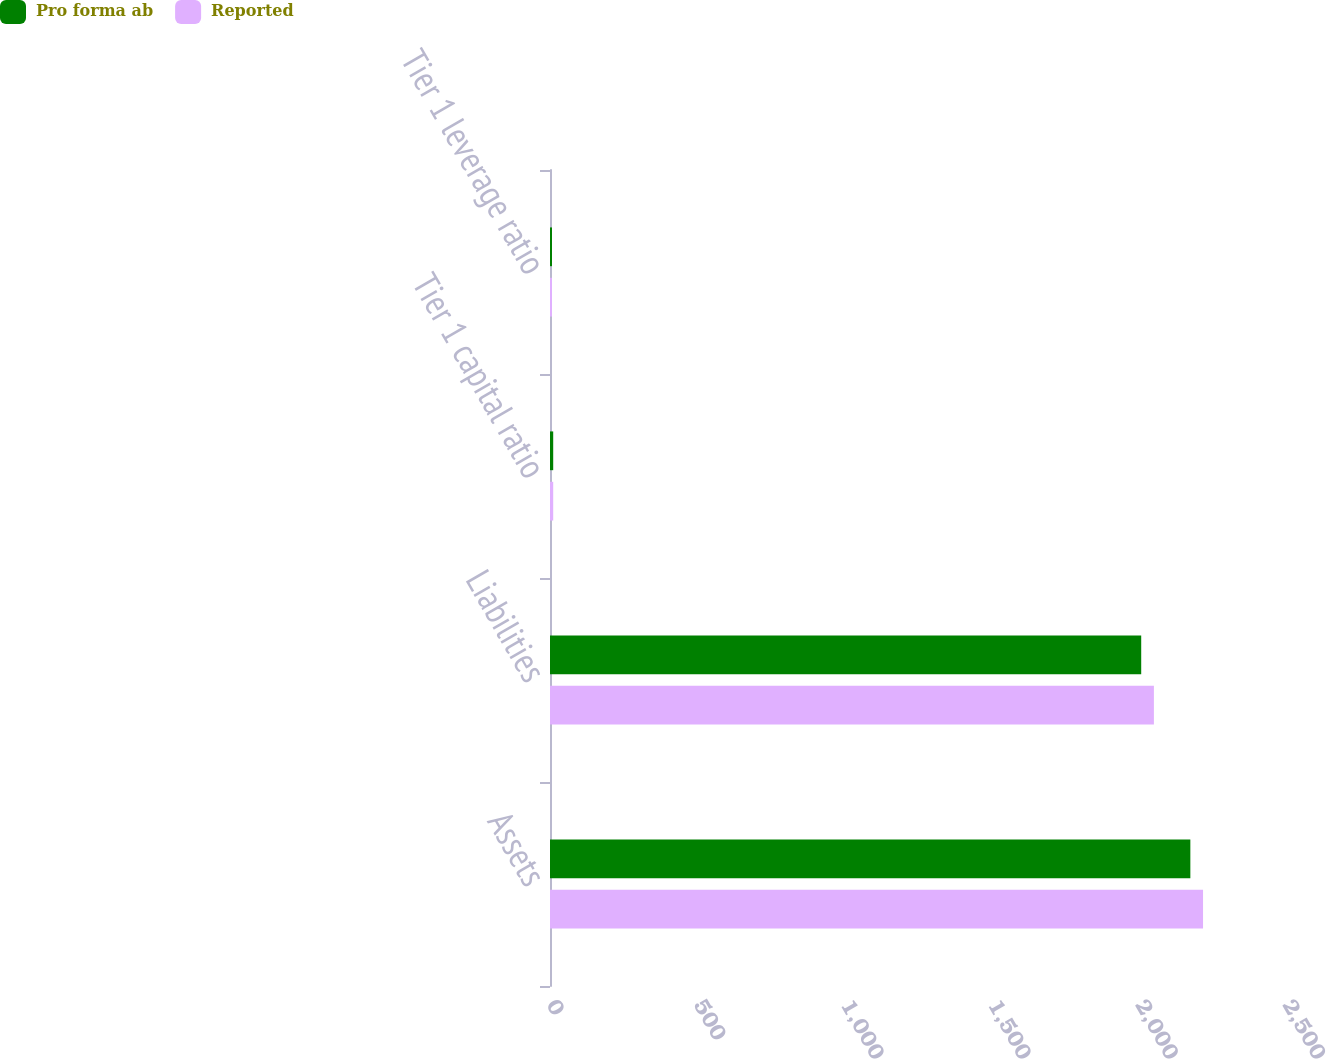<chart> <loc_0><loc_0><loc_500><loc_500><stacked_bar_chart><ecel><fcel>Assets<fcel>Liabilities<fcel>Tier 1 capital ratio<fcel>Tier 1 leverage ratio<nl><fcel>Pro forma ab<fcel>2175.1<fcel>2008.2<fcel>10.9<fcel>6.9<nl><fcel>Reported<fcel>2218.2<fcel>2051.3<fcel>10.9<fcel>6.8<nl></chart> 